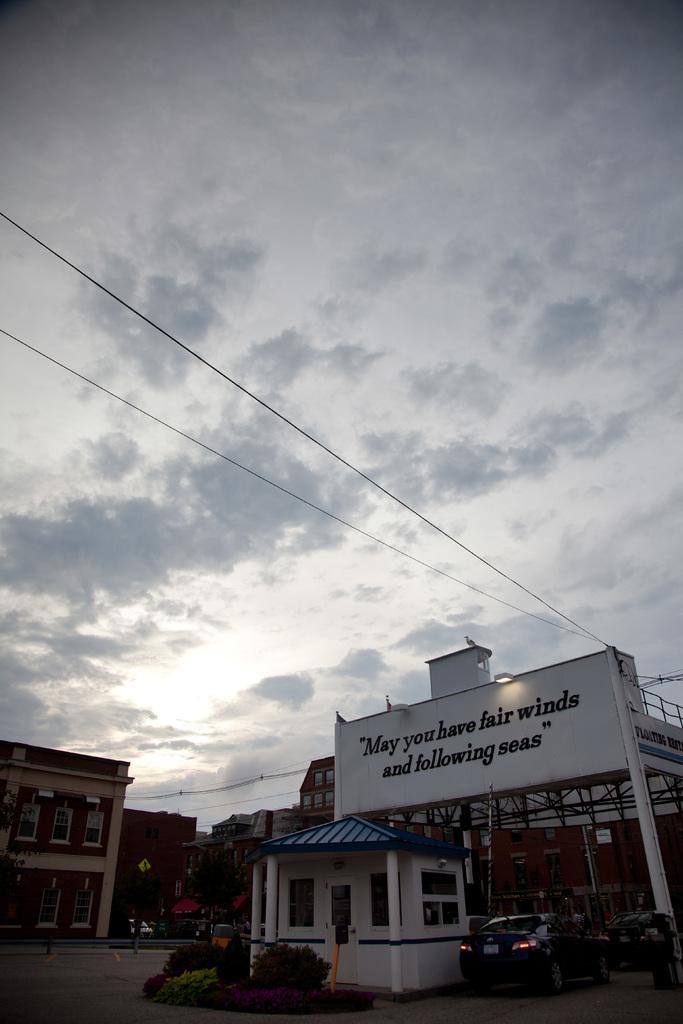How would you summarize this image in a sentence or two? Here in this picture we can see buildings present all over there and in the front we can see a board present, on which we can see some text written on it over there and we can see a light present on it over there and on the ground we can see a car present and we can see some plants present over there and in the sky we can see clouds present over there. 